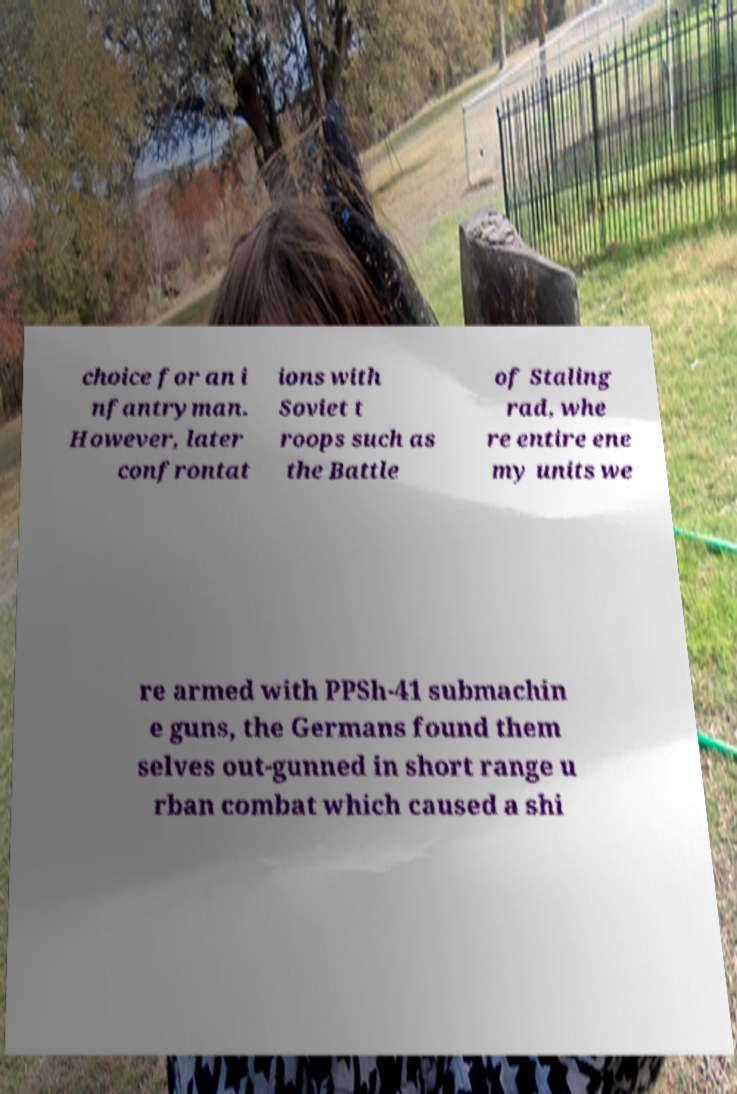What messages or text are displayed in this image? I need them in a readable, typed format. choice for an i nfantryman. However, later confrontat ions with Soviet t roops such as the Battle of Staling rad, whe re entire ene my units we re armed with PPSh-41 submachin e guns, the Germans found them selves out-gunned in short range u rban combat which caused a shi 